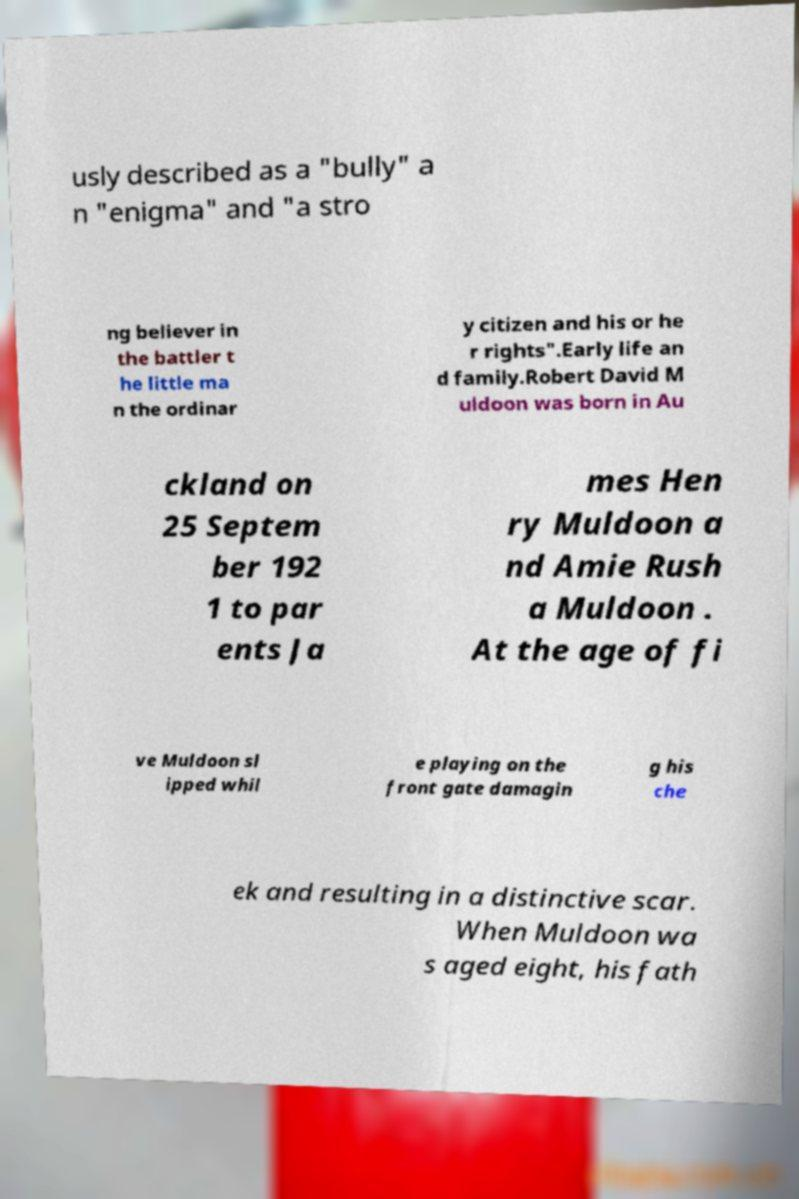There's text embedded in this image that I need extracted. Can you transcribe it verbatim? usly described as a "bully" a n "enigma" and "a stro ng believer in the battler t he little ma n the ordinar y citizen and his or he r rights".Early life an d family.Robert David M uldoon was born in Au ckland on 25 Septem ber 192 1 to par ents Ja mes Hen ry Muldoon a nd Amie Rush a Muldoon . At the age of fi ve Muldoon sl ipped whil e playing on the front gate damagin g his che ek and resulting in a distinctive scar. When Muldoon wa s aged eight, his fath 